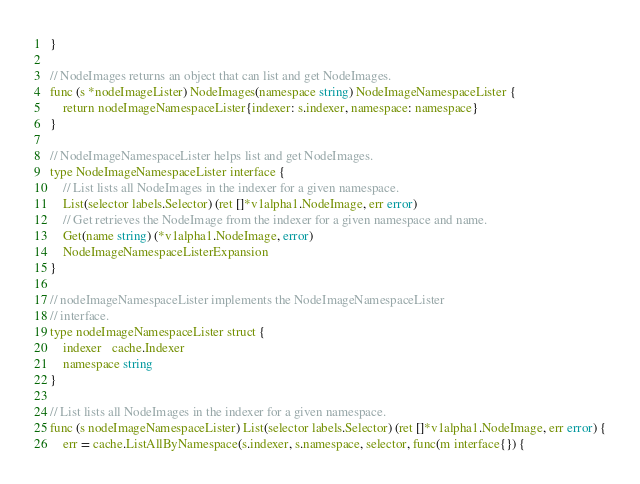<code> <loc_0><loc_0><loc_500><loc_500><_Go_>}

// NodeImages returns an object that can list and get NodeImages.
func (s *nodeImageLister) NodeImages(namespace string) NodeImageNamespaceLister {
	return nodeImageNamespaceLister{indexer: s.indexer, namespace: namespace}
}

// NodeImageNamespaceLister helps list and get NodeImages.
type NodeImageNamespaceLister interface {
	// List lists all NodeImages in the indexer for a given namespace.
	List(selector labels.Selector) (ret []*v1alpha1.NodeImage, err error)
	// Get retrieves the NodeImage from the indexer for a given namespace and name.
	Get(name string) (*v1alpha1.NodeImage, error)
	NodeImageNamespaceListerExpansion
}

// nodeImageNamespaceLister implements the NodeImageNamespaceLister
// interface.
type nodeImageNamespaceLister struct {
	indexer   cache.Indexer
	namespace string
}

// List lists all NodeImages in the indexer for a given namespace.
func (s nodeImageNamespaceLister) List(selector labels.Selector) (ret []*v1alpha1.NodeImage, err error) {
	err = cache.ListAllByNamespace(s.indexer, s.namespace, selector, func(m interface{}) {</code> 